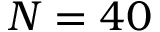<formula> <loc_0><loc_0><loc_500><loc_500>N = 4 0</formula> 